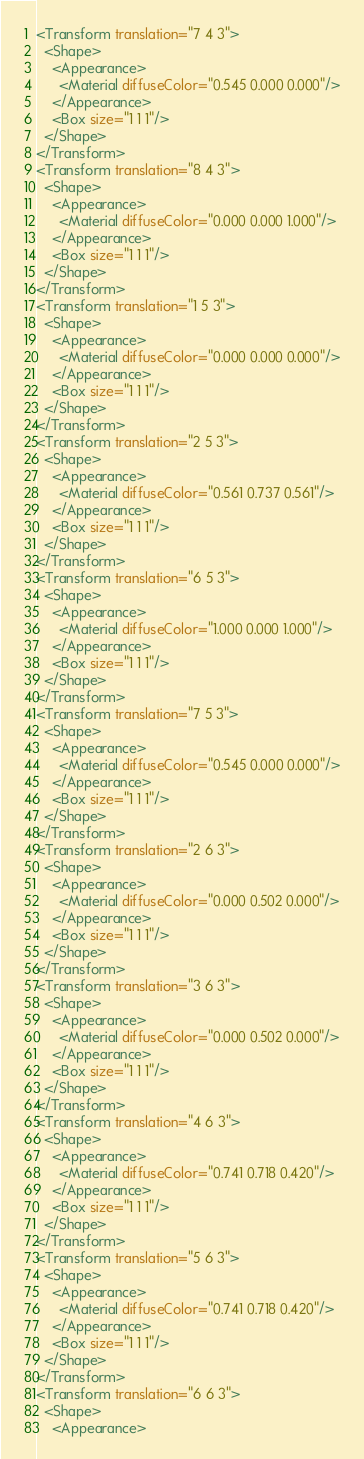Convert code to text. <code><loc_0><loc_0><loc_500><loc_500><_XML_><Transform translation="7 4 3">
  <Shape>
    <Appearance>
      <Material diffuseColor="0.545 0.000 0.000"/>
    </Appearance>
    <Box size="1 1 1"/>
  </Shape>
</Transform>
<Transform translation="8 4 3">
  <Shape>
    <Appearance>
      <Material diffuseColor="0.000 0.000 1.000"/>
    </Appearance>
    <Box size="1 1 1"/>
  </Shape>
</Transform>
<Transform translation="1 5 3">
  <Shape>
    <Appearance>
      <Material diffuseColor="0.000 0.000 0.000"/>
    </Appearance>
    <Box size="1 1 1"/>
  </Shape>
</Transform>
<Transform translation="2 5 3">
  <Shape>
    <Appearance>
      <Material diffuseColor="0.561 0.737 0.561"/>
    </Appearance>
    <Box size="1 1 1"/>
  </Shape>
</Transform>
<Transform translation="6 5 3">
  <Shape>
    <Appearance>
      <Material diffuseColor="1.000 0.000 1.000"/>
    </Appearance>
    <Box size="1 1 1"/>
  </Shape>
</Transform>
<Transform translation="7 5 3">
  <Shape>
    <Appearance>
      <Material diffuseColor="0.545 0.000 0.000"/>
    </Appearance>
    <Box size="1 1 1"/>
  </Shape>
</Transform>
<Transform translation="2 6 3">
  <Shape>
    <Appearance>
      <Material diffuseColor="0.000 0.502 0.000"/>
    </Appearance>
    <Box size="1 1 1"/>
  </Shape>
</Transform>
<Transform translation="3 6 3">
  <Shape>
    <Appearance>
      <Material diffuseColor="0.000 0.502 0.000"/>
    </Appearance>
    <Box size="1 1 1"/>
  </Shape>
</Transform>
<Transform translation="4 6 3">
  <Shape>
    <Appearance>
      <Material diffuseColor="0.741 0.718 0.420"/>
    </Appearance>
    <Box size="1 1 1"/>
  </Shape>
</Transform>
<Transform translation="5 6 3">
  <Shape>
    <Appearance>
      <Material diffuseColor="0.741 0.718 0.420"/>
    </Appearance>
    <Box size="1 1 1"/>
  </Shape>
</Transform>
<Transform translation="6 6 3">
  <Shape>
    <Appearance></code> 